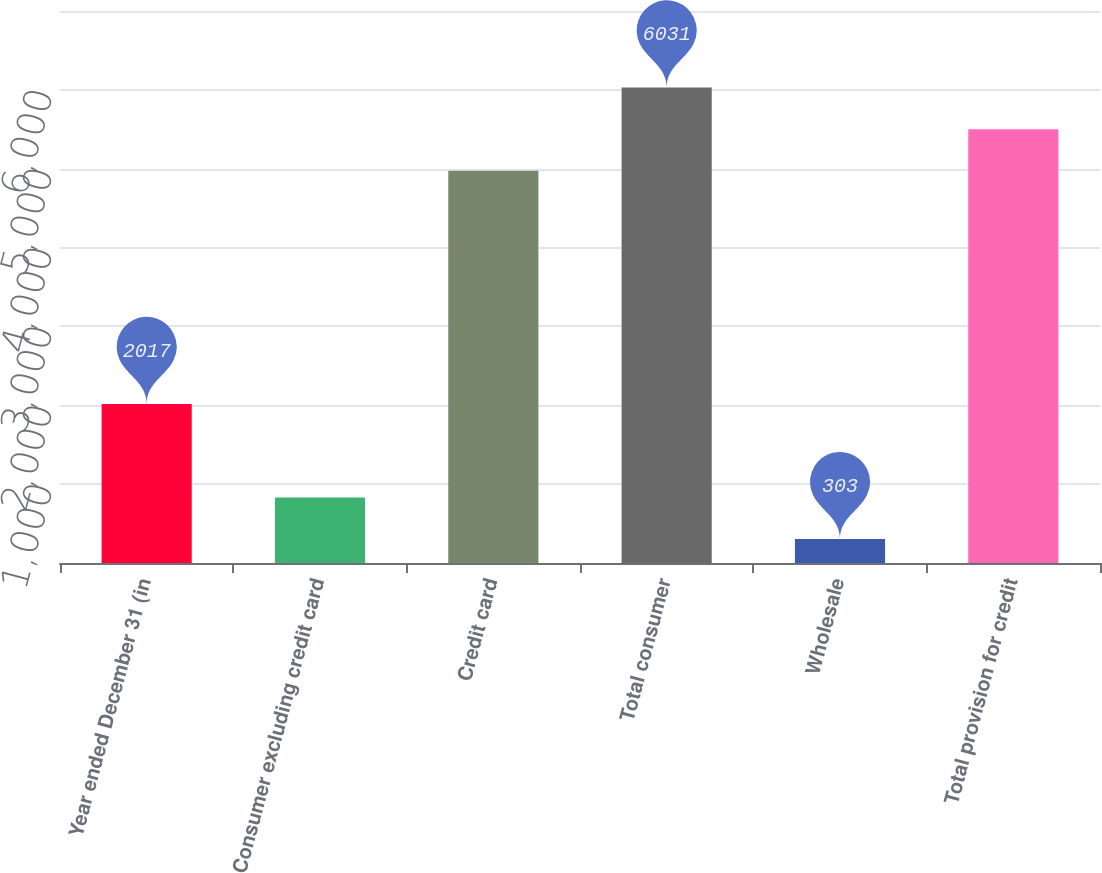Convert chart. <chart><loc_0><loc_0><loc_500><loc_500><bar_chart><fcel>Year ended December 31 (in<fcel>Consumer excluding credit card<fcel>Credit card<fcel>Total consumer<fcel>Wholesale<fcel>Total provision for credit<nl><fcel>2017<fcel>832<fcel>4973<fcel>6031<fcel>303<fcel>5502<nl></chart> 